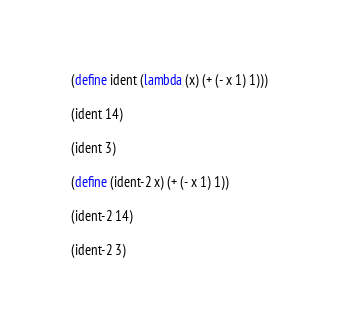Convert code to text. <code><loc_0><loc_0><loc_500><loc_500><_Racket_>(define ident (lambda (x) (+ (- x 1) 1)))

(ident 14)

(ident 3)

(define (ident-2 x) (+ (- x 1) 1))

(ident-2 14)

(ident-2 3)
</code> 